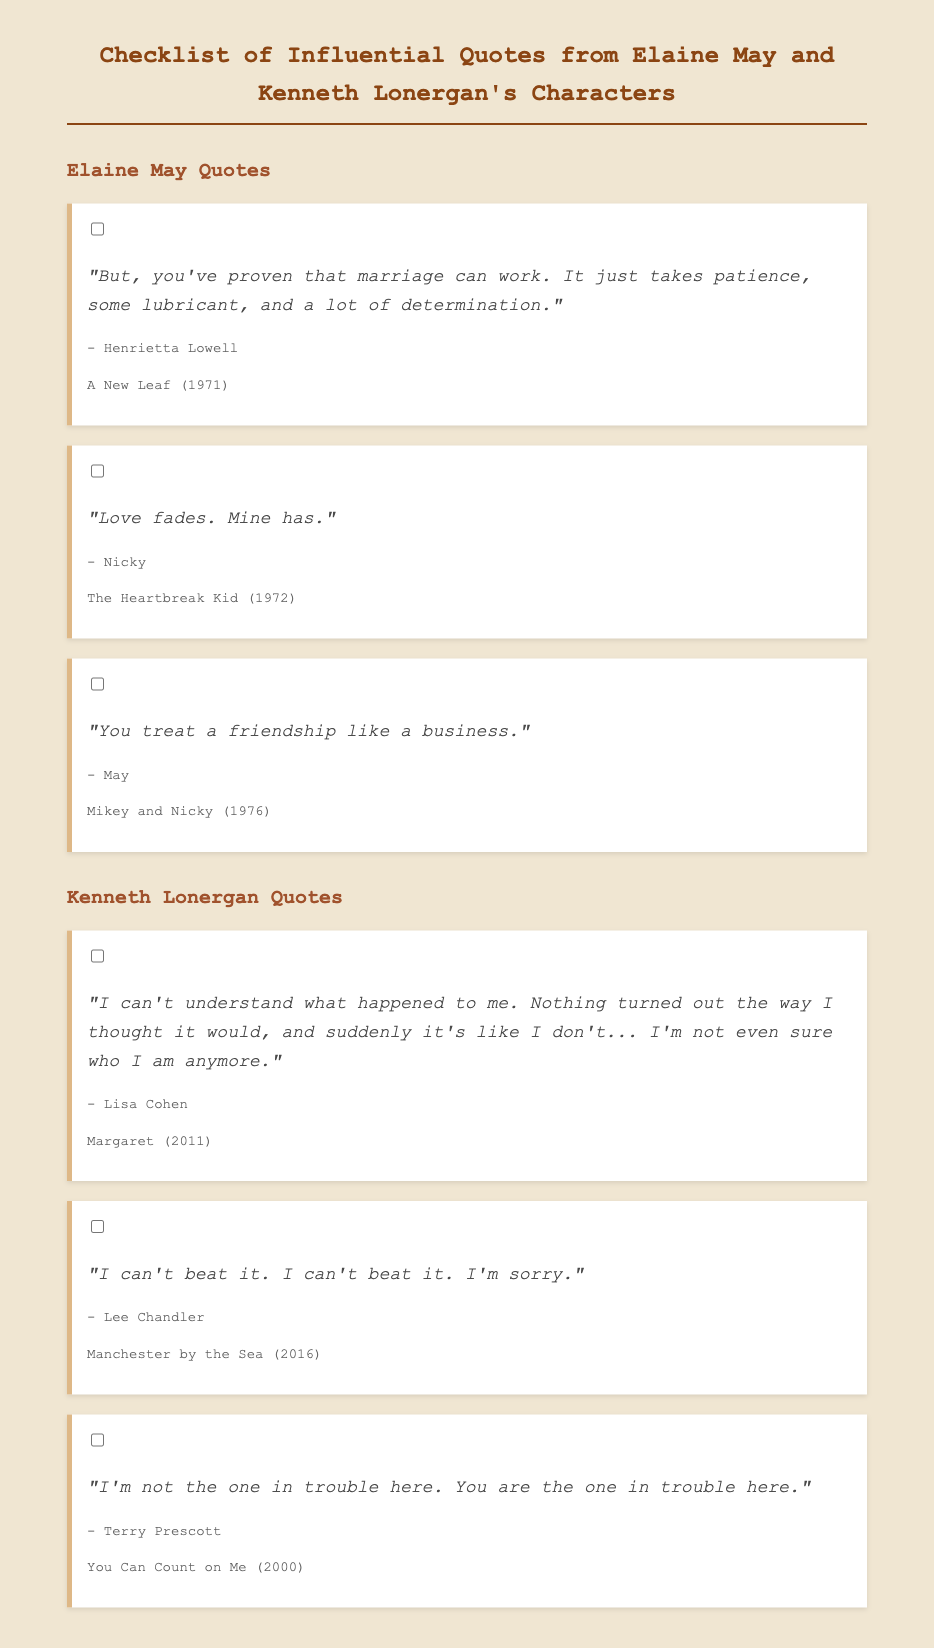What movie features Henrietta Lowell's quote? The quote by Henrietta Lowell is from the movie "A New Leaf."
Answer: A New Leaf Who says "Love fades. Mine has."? The quote "Love fades. Mine has." is said by the character Nicky.
Answer: Nicky Which character expresses the thought about friendship as a business? The character who expresses this thought is May.
Answer: May In which film does Lisa Cohen appear? The character Lisa Cohen appears in the movie "Margaret."
Answer: Margaret What is the main sentiment expressed by Lee Chandler in his quote? Lee Chandler's quote expresses a feeling of defeat and apology.
Answer: Can't beat it Who is deemed to be "in trouble" according to Terry Prescott? According to Terry Prescott, the person in trouble is implied to be the listener or another character.
Answer: You How many quotes are attributed to Kenneth Lonergan's characters? There are three quotes attributed to Kenneth Lonergan's characters in the document.
Answer: Three What emotional state is depicted in the quote by Lisa Cohen? The quote by Lisa Cohen depicts confusion and a loss of identity.
Answer: Confusion What color is the background of the document? The background of the document is a light beige color.
Answer: Light beige 